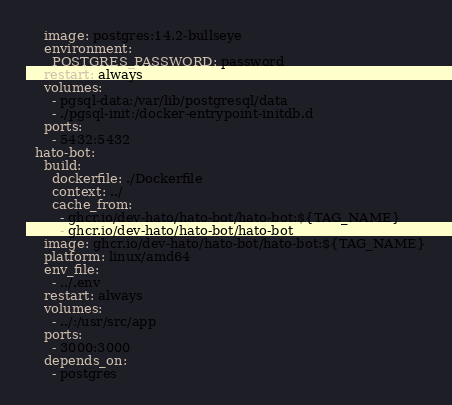<code> <loc_0><loc_0><loc_500><loc_500><_YAML_>    image: postgres:14.2-bullseye
    environment:
      POSTGRES_PASSWORD: password
    restart: always
    volumes:
      - pgsql-data:/var/lib/postgresql/data
      - ./pgsql-init:/docker-entrypoint-initdb.d
    ports:
      - 5432:5432
  hato-bot:
    build:
      dockerfile: ./Dockerfile
      context: ../
      cache_from:
        - ghcr.io/dev-hato/hato-bot/hato-bot:${TAG_NAME}
        - ghcr.io/dev-hato/hato-bot/hato-bot
    image: ghcr.io/dev-hato/hato-bot/hato-bot:${TAG_NAME}
    platform: linux/amd64
    env_file:
      - ../.env
    restart: always
    volumes:
      - ../:/usr/src/app
    ports:
      - 3000:3000
    depends_on:
      - postgres
</code> 